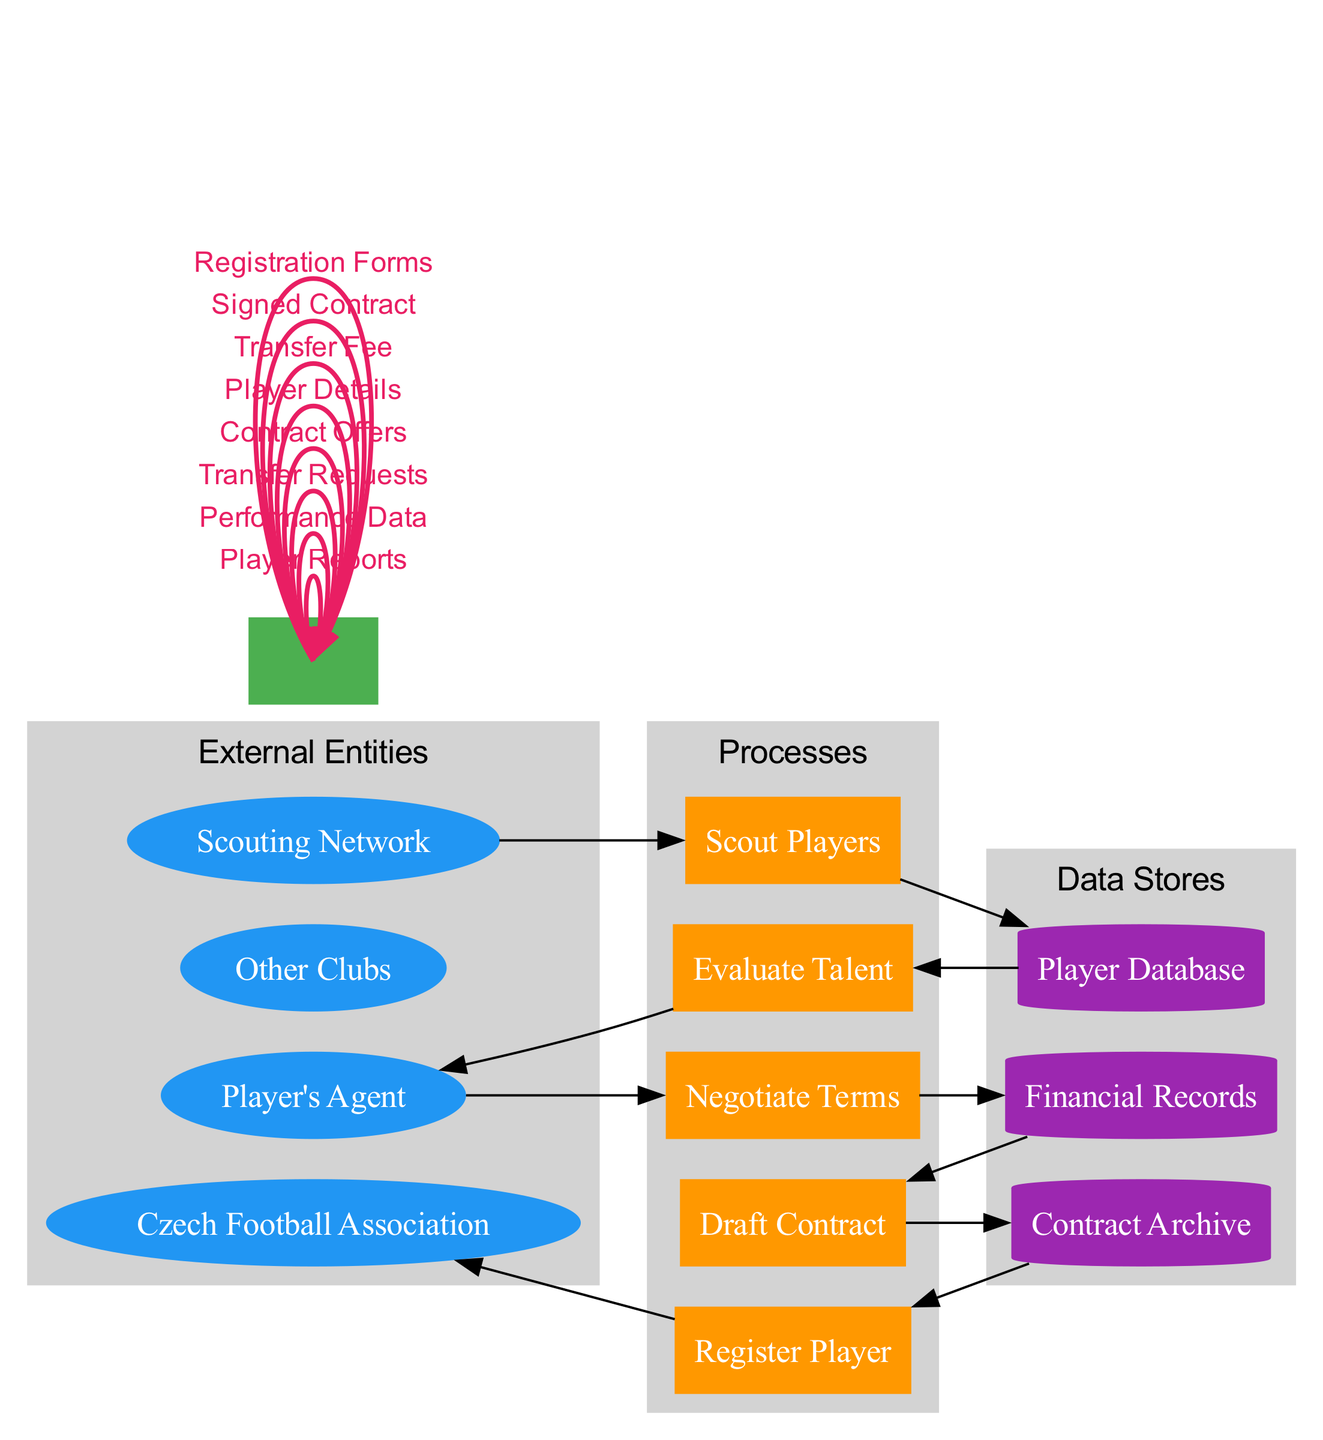What are the external entities involved in the player transfer process? The diagram lists four external entities: Scouting Network, Player's Agent, Other Clubs, and Czech Football Association. These are the parties that interact with FC Zbrojovka Brno during the transfer process.
Answer: Scouting Network, Player's Agent, Other Clubs, Czech Football Association How many processes are shown in the diagram? The diagram shows five processes listed under the Processes section: Scout Players, Evaluate Talent, Negotiate Terms, Draft Contract, and Register Player. To find the number, we simply count these processes.
Answer: 5 Which data store is used to keep financial information? Financial Records is the specific data store identified in the diagram for maintaining financial information related to player transfers and contracts.
Answer: Financial Records What is the first process in the player transfer flow? The first process identified in the diagram is Scout Players, which initiates the entire player transfer flow as represented by its position in the flow sequence.
Answer: Scout Players Which external entity provides Player Reports? The external entity that provides Player Reports, as depicted in the data flows, is the Scouting Network. The connection from this entity indicates its role in submitting reports on potential players.
Answer: Scouting Network How does the process of negotiating terms connect to the financial records? The process of Negotiate Terms is connected to Financial Records, indicating that the negotiation of player contracts and terms relies on the financial information stored there. This demonstrates the flow of necessary data from negotiation to financial assessment.
Answer: Financial Records How many data flows are represented in the diagram? The diagram displays eight data flows connecting various nodes within the player transfer process. We can identify each flow from the data flows section and count them.
Answer: 8 Which process precedes the drafting of the contract? The process that precedes Draft Contract is Negotiate Terms, as indicated by the sequential flow from negotiating player terms to preparing the contract, showing the logical order of steps in the transfer process.
Answer: Negotiate Terms How is the player finally registered after the contract signing? After the contract is drafted and signed, the Register Player process is performed, which connects to the Czech Football Association, indicating that registration is the final step to complete the transfer process.
Answer: Czech Football Association 